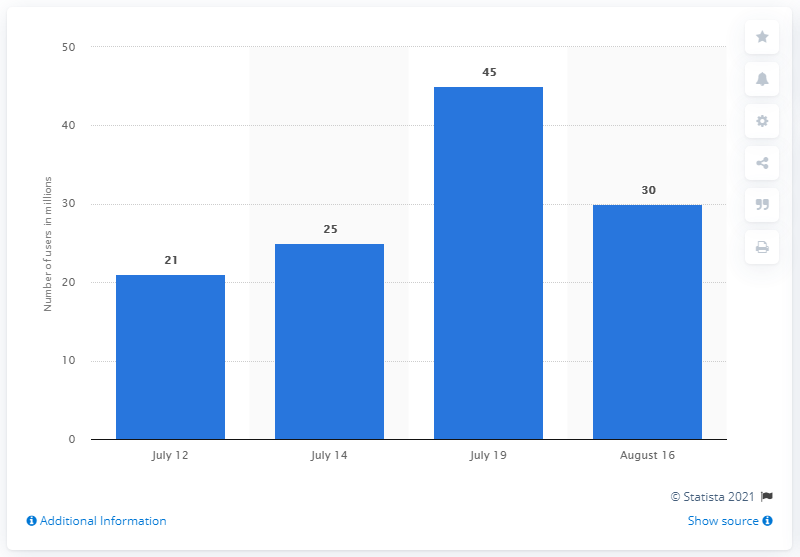Indicate a few pertinent items in this graphic. On July 19, the daily active users of Pokemon GO reached 45. As of August 16, 2016, the daily active users of Pokemon GO were approximately 30. As of the year 2019, the number of daily active users of Pokemon GO in the United States was approximately 21 million. 